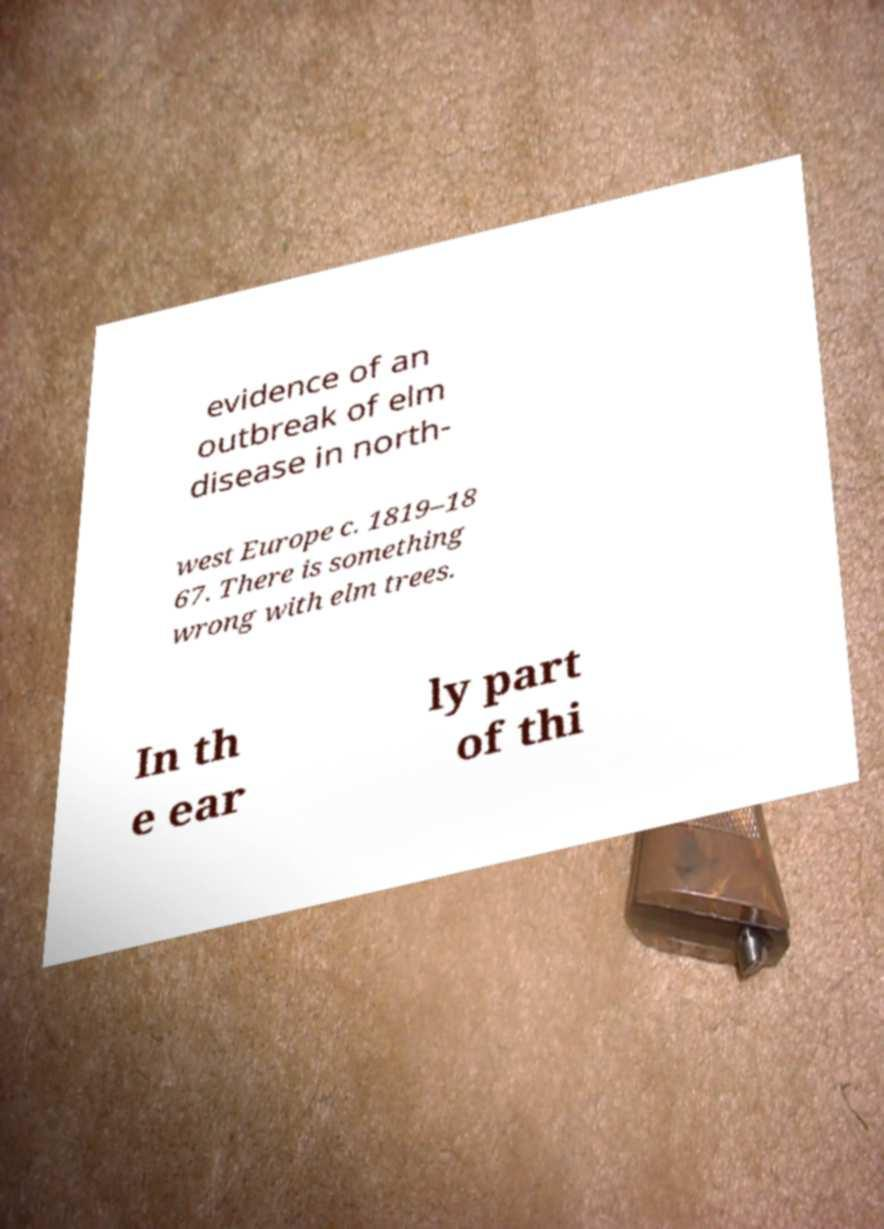I need the written content from this picture converted into text. Can you do that? evidence of an outbreak of elm disease in north- west Europe c. 1819–18 67. There is something wrong with elm trees. In th e ear ly part of thi 